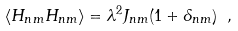Convert formula to latex. <formula><loc_0><loc_0><loc_500><loc_500>\langle H _ { n m } H _ { n m } \rangle = \lambda ^ { 2 } J _ { n m } ( 1 + \delta _ { n m } ) \ ,</formula> 